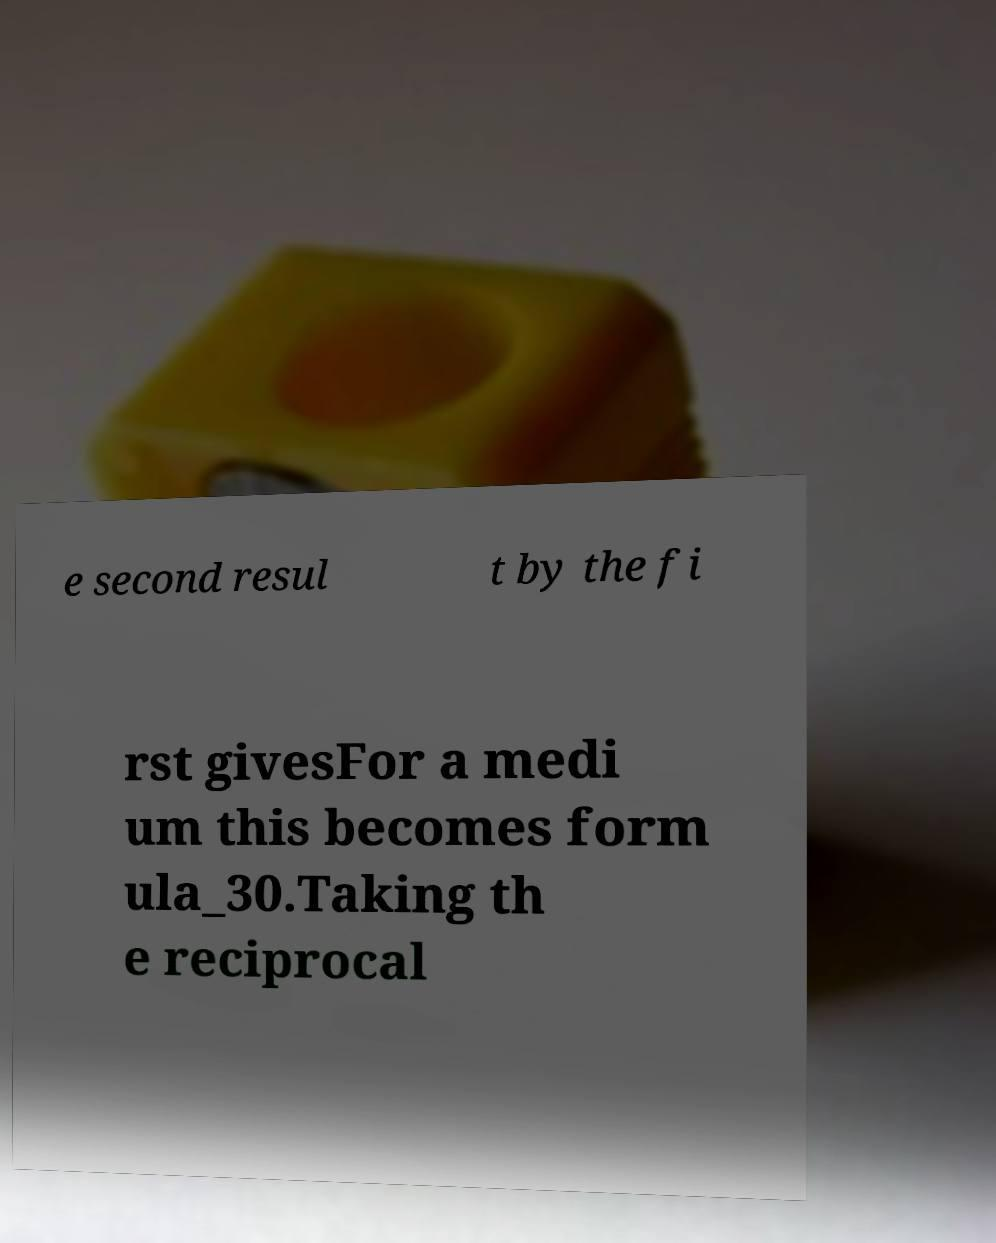Please identify and transcribe the text found in this image. e second resul t by the fi rst givesFor a medi um this becomes form ula_30.Taking th e reciprocal 